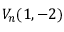<formula> <loc_0><loc_0><loc_500><loc_500>V _ { n } ( 1 , - 2 )</formula> 